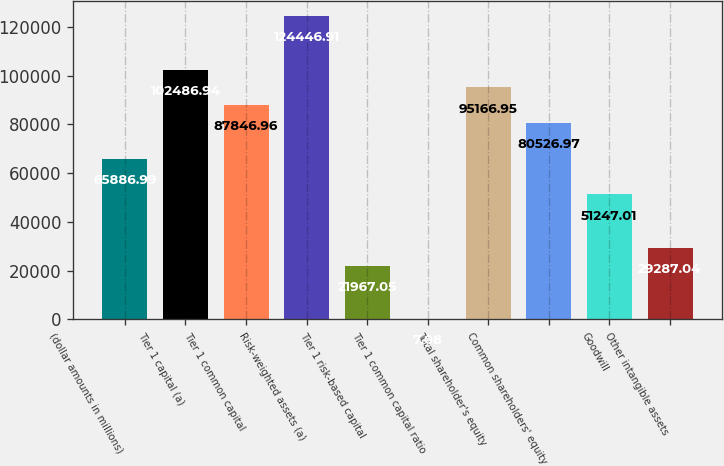<chart> <loc_0><loc_0><loc_500><loc_500><bar_chart><fcel>(dollar amounts in millions)<fcel>Tier 1 capital (a)<fcel>Tier 1 common capital<fcel>Risk-weighted assets (a)<fcel>Tier 1 risk-based capital<fcel>Tier 1 common capital ratio<fcel>Total shareholder's equity<fcel>Common shareholders' equity<fcel>Goodwill<fcel>Other intangible assets<nl><fcel>65887<fcel>102487<fcel>87847<fcel>124447<fcel>21967<fcel>7.08<fcel>95166.9<fcel>80527<fcel>51247<fcel>29287<nl></chart> 